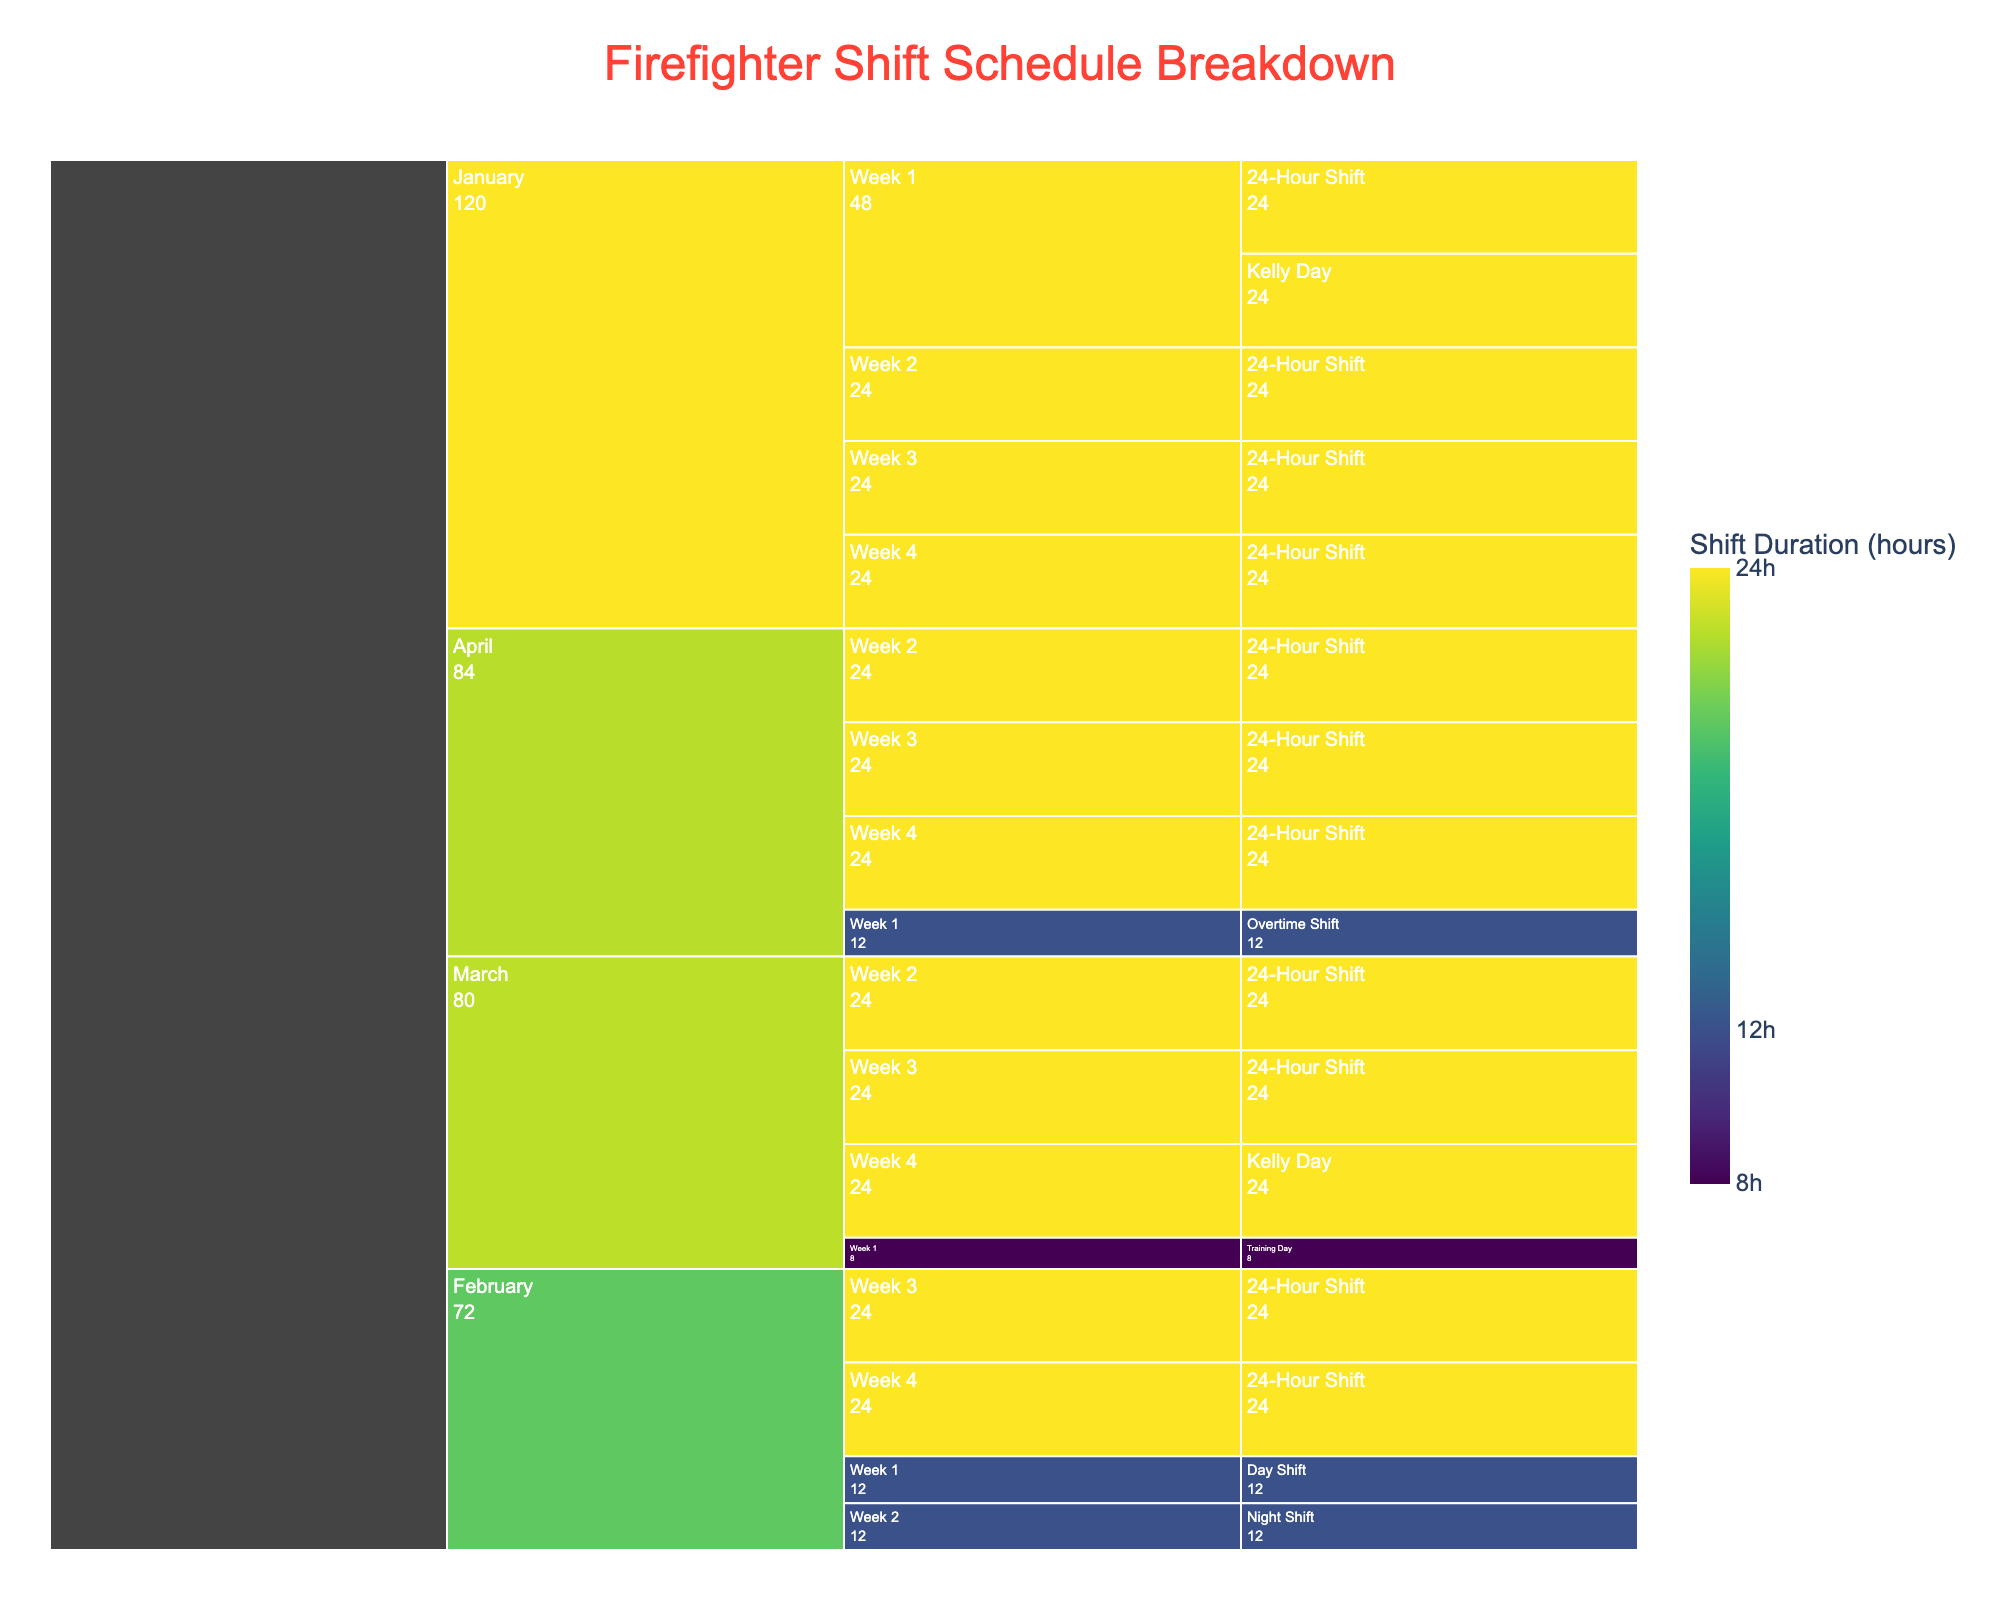Which month has the most types of shifts? January shows "24-Hour Shift", "Kelly Day". February has "Day Shift", "Night Shift", "24-Hour Shift". March contains "Training Day", "24-Hour Shift", "Kelly Day". April features "Overtime Shift", "24-Hour Shift". March and February both have three types of shifts.
Answer: March and February What is the total duration of 24-Hour Shifts in January? Summing the durations of all "24-Hour Shift" within January: 24 (Week 1) + 24 (Week 2) + 24 (Week 3) + 24 (Week 4) equals 96 hours.
Answer: 96 hours Which week in February has the shortest shift duration? February includes "Day Shift" (Week 1: 12 hours) and "Night Shift" (Week 2: 12 hours), and "24-Hour Shift" (Weeks 3 and 4: 24 hours each). The shortest are in Week 1 and Week 2 (both 12 hours).
Answer: Week 1 and Week 2 How many 24-Hour Shifts occur in March? From the chart, March has two boxes labeled "24-Hour Shift".
Answer: 2 Which month has the longest duration for a single shift? All months except March display 24-hour shifts, while the longest in March is 24-hour, present in multiple months equally.
Answer: Tied (January, February, March, April) What is the total duration for all shifts in Week 1 across the entire period? Summing the durations of all shifts in Week 1: January (24-hour 24 + Kelly 24), February (Day 12), March (Training 8), and April (Overtime 12) totals 24 + 24 + 12 + 8 + 12 = 80 hours.
Answer: 80 hours Which shift type occurs most frequently in the data? "24-Hour Shift" appears the most by counting its boxes across all months and weeks.
Answer: 9 times 